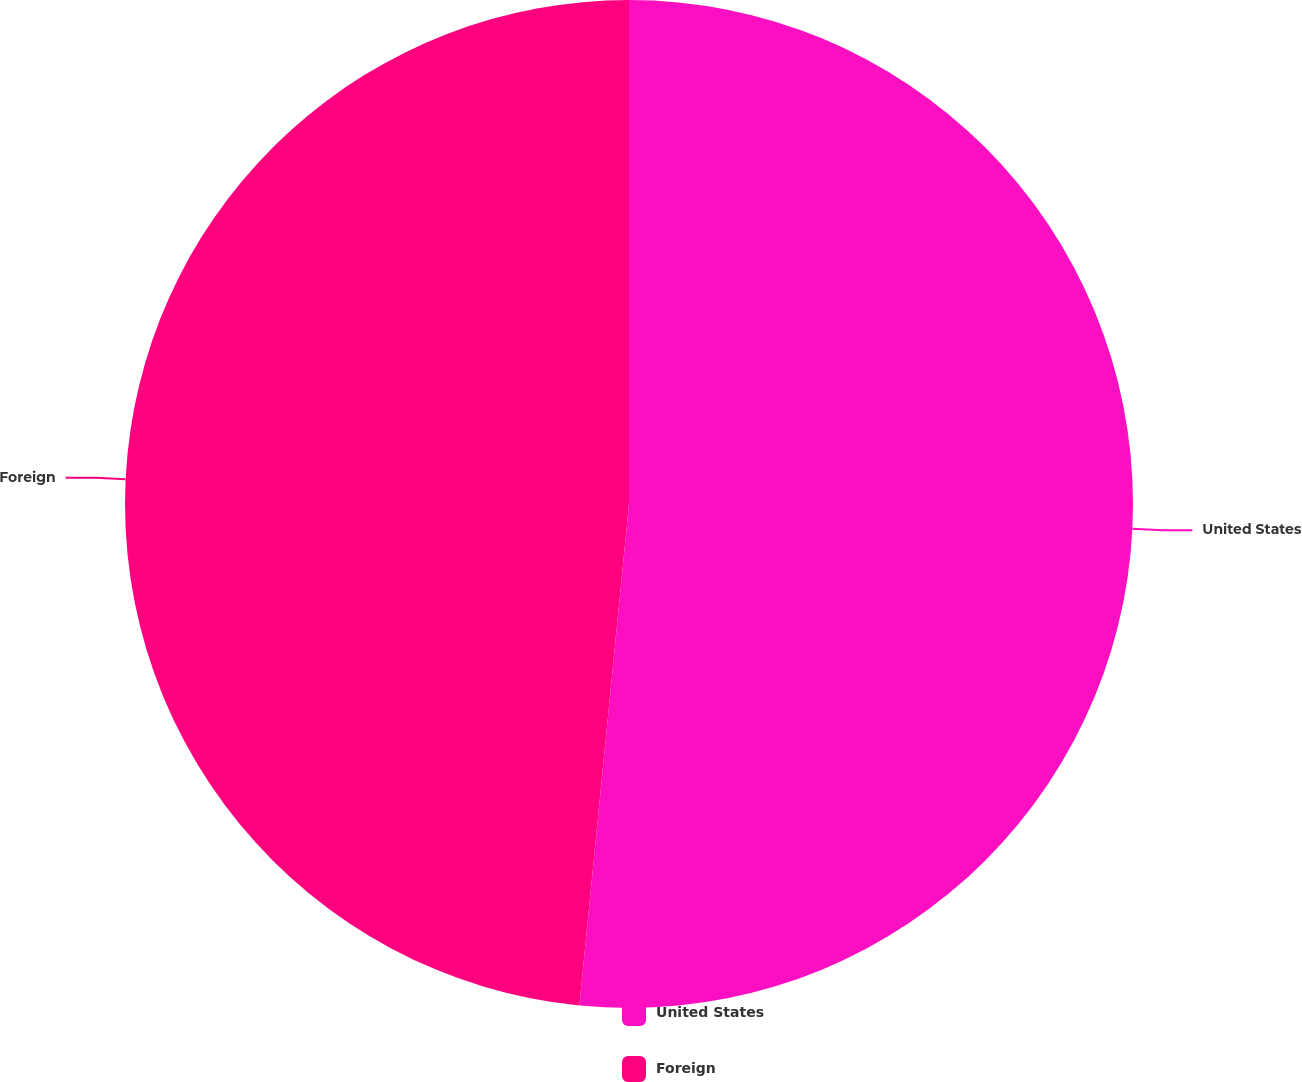Convert chart. <chart><loc_0><loc_0><loc_500><loc_500><pie_chart><fcel>United States<fcel>Foreign<nl><fcel>51.57%<fcel>48.43%<nl></chart> 